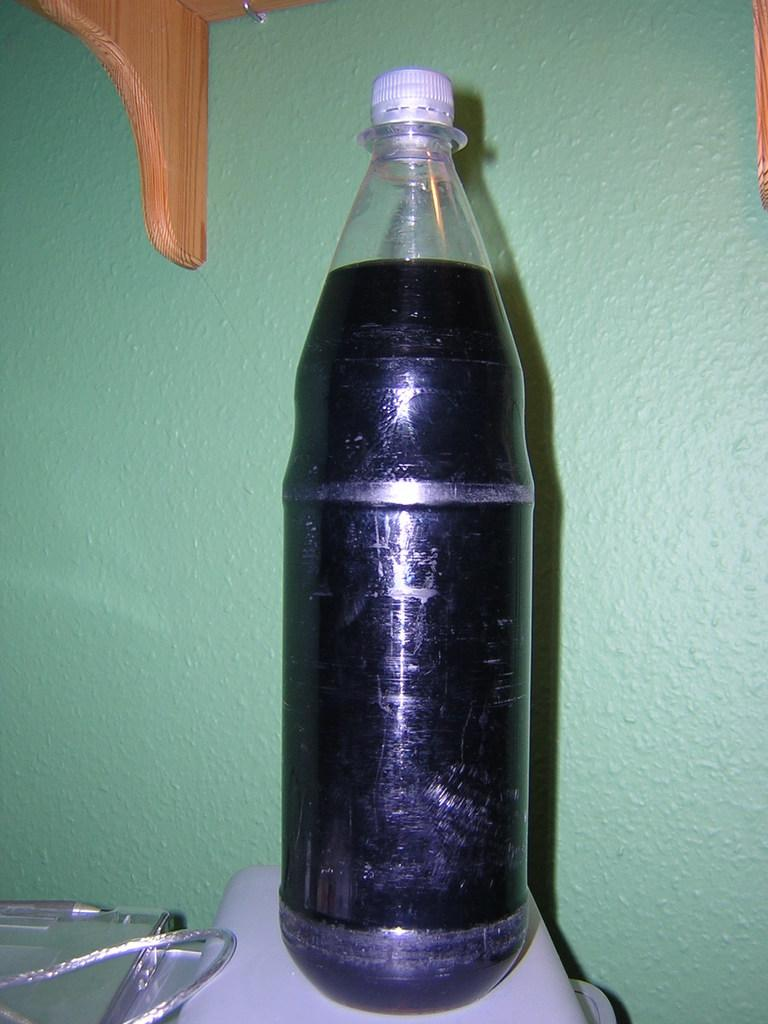What object is present in the image that typically contains a liquid? There is a bottle in the image. What type of liquid is inside the bottle? The bottle contains a black-colored drink. What color is the wall behind the bottle? There is a green-colored wall behind the bottle. Can you tell me how the camera is positioned in the image? There is no camera present in the image. What type of request is being made by the giraffe in the image? There is no giraffe present in the image. 